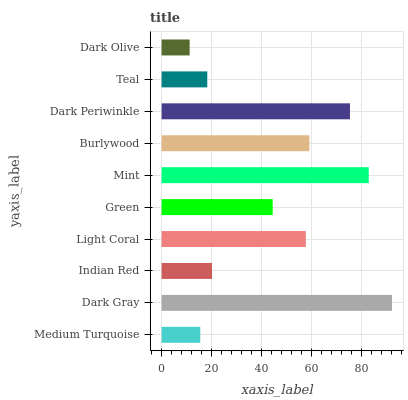Is Dark Olive the minimum?
Answer yes or no. Yes. Is Dark Gray the maximum?
Answer yes or no. Yes. Is Indian Red the minimum?
Answer yes or no. No. Is Indian Red the maximum?
Answer yes or no. No. Is Dark Gray greater than Indian Red?
Answer yes or no. Yes. Is Indian Red less than Dark Gray?
Answer yes or no. Yes. Is Indian Red greater than Dark Gray?
Answer yes or no. No. Is Dark Gray less than Indian Red?
Answer yes or no. No. Is Light Coral the high median?
Answer yes or no. Yes. Is Green the low median?
Answer yes or no. Yes. Is Green the high median?
Answer yes or no. No. Is Indian Red the low median?
Answer yes or no. No. 